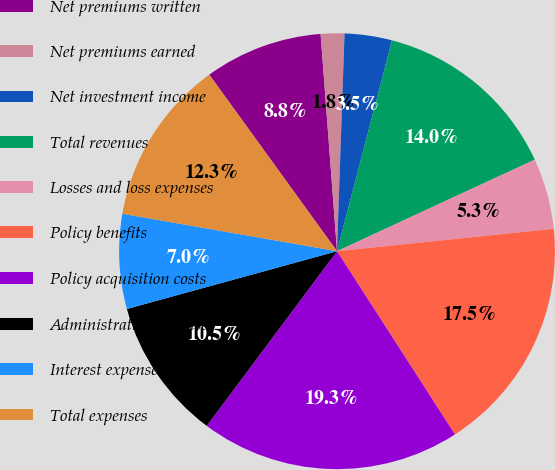Convert chart. <chart><loc_0><loc_0><loc_500><loc_500><pie_chart><fcel>Net premiums written<fcel>Net premiums earned<fcel>Net investment income<fcel>Total revenues<fcel>Losses and loss expenses<fcel>Policy benefits<fcel>Policy acquisition costs<fcel>Administrative expenses<fcel>Interest expense<fcel>Total expenses<nl><fcel>8.77%<fcel>1.75%<fcel>3.51%<fcel>14.04%<fcel>5.26%<fcel>17.54%<fcel>19.3%<fcel>10.53%<fcel>7.02%<fcel>12.28%<nl></chart> 